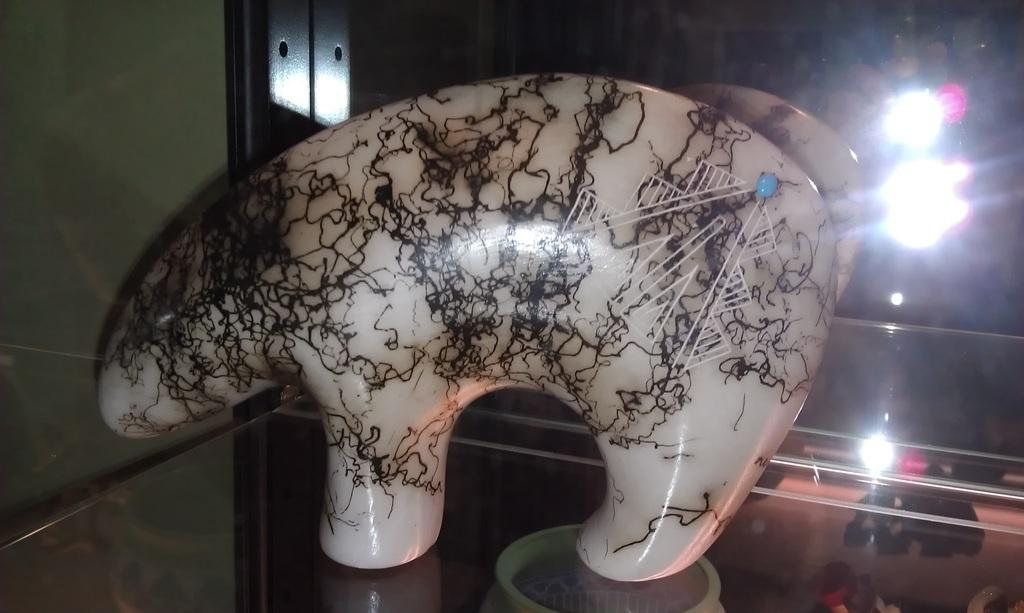What is the main subject of the image? There is a statue in the image. Where is the statue placed? The statue is on a glass table. What can be seen on the left side of the image? There is a wall on the left side of the image. What is visible in the background of the image? There are focus slides visible in the background of the image. How many mice are climbing on the statue in the image? There are no mice present in the image; the statue is the main subject. 